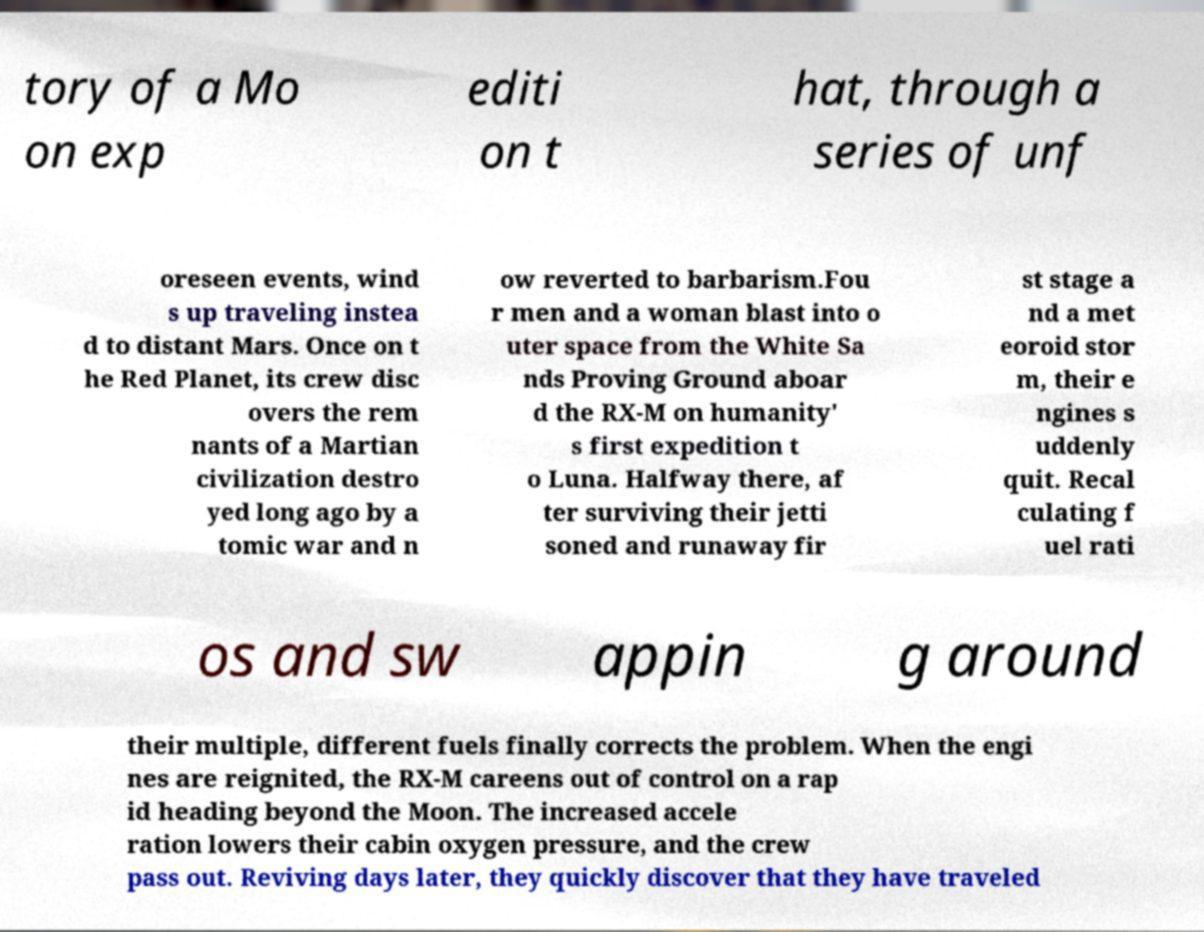For documentation purposes, I need the text within this image transcribed. Could you provide that? tory of a Mo on exp editi on t hat, through a series of unf oreseen events, wind s up traveling instea d to distant Mars. Once on t he Red Planet, its crew disc overs the rem nants of a Martian civilization destro yed long ago by a tomic war and n ow reverted to barbarism.Fou r men and a woman blast into o uter space from the White Sa nds Proving Ground aboar d the RX-M on humanity' s first expedition t o Luna. Halfway there, af ter surviving their jetti soned and runaway fir st stage a nd a met eoroid stor m, their e ngines s uddenly quit. Recal culating f uel rati os and sw appin g around their multiple, different fuels finally corrects the problem. When the engi nes are reignited, the RX-M careens out of control on a rap id heading beyond the Moon. The increased accele ration lowers their cabin oxygen pressure, and the crew pass out. Reviving days later, they quickly discover that they have traveled 